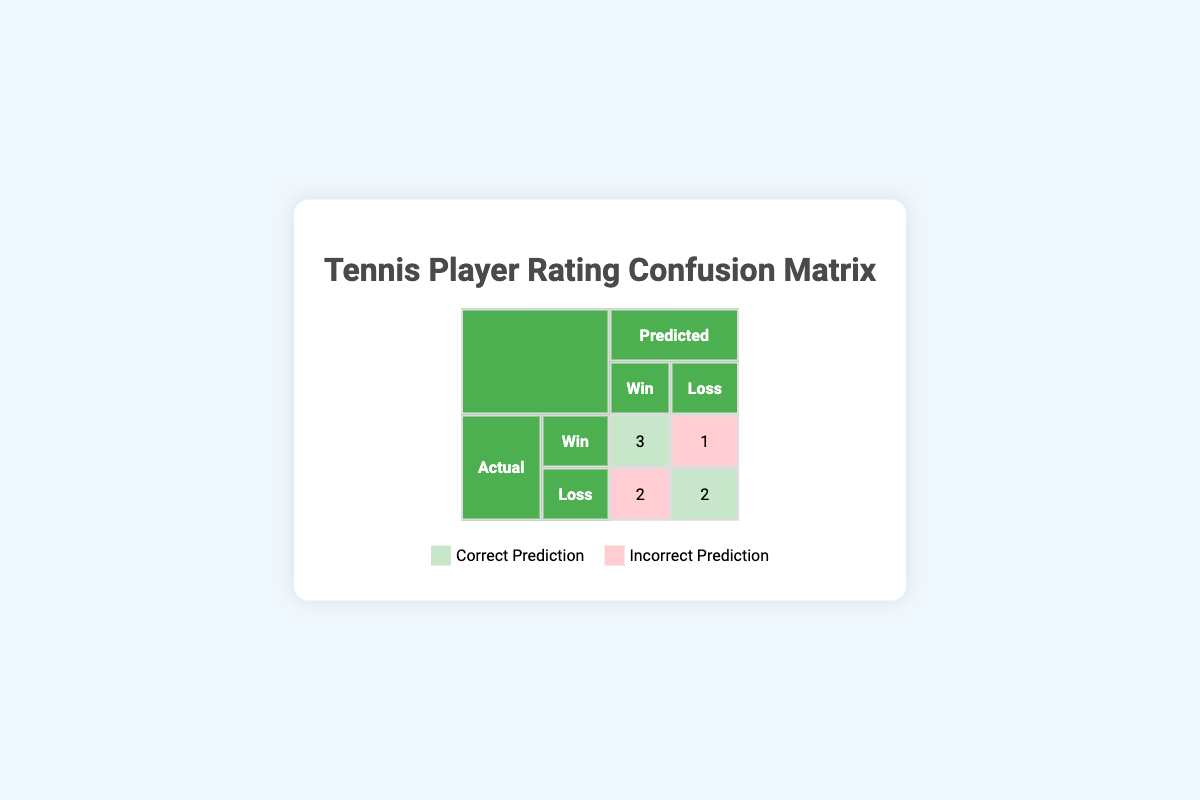What is the total number of true positives in the confusion matrix? The confusion matrix shows that there are 3 true positives, which represent the players correctly predicted to win and actually did win.
Answer: 3 How many players were incorrectly predicted to win? The confusion matrix indicates there are 2 false positives, which means 2 players were predicted to win but actually lost.
Answer: 2 What is the total number of players whose match outcomes were predicted accurately? The total accurate predictions (true positives plus true negatives) are 3 (true positives) + 2 (true negatives) = 5 players.
Answer: 5 Is it true that there are more false negatives than false positives? From the confusion matrix, there is 1 false negative and 2 false positives; hence, it is false that there are more false negatives than false positives.
Answer: No What is the percentage of correct predictions out of all predictions made? The total number of predictions made is 8 (sum of all entries in the matrix). The correct predictions are 5. To find the percentage: (5 correct predictions / 8 total predictions) * 100 = 62.5%.
Answer: 62.5% If we combine the results, what is the ratio of correctly predicted wins to total wins? There are 3 correctly predicted wins (true positives) and a total of 4 actual wins (3 true positives + 1 false negative). The ratio is 3:4.
Answer: 3:4 Which player was the only one predicted to win but actually lost? Referring to the data, the player predicted to win but actually lost is Andrew Jones.
Answer: Andrew Jones How many players had their match outcome predicted as a loss? The confusion matrix indicates that 3 players had predicted losses (2 false positives + 2 true negatives).
Answer: 4 